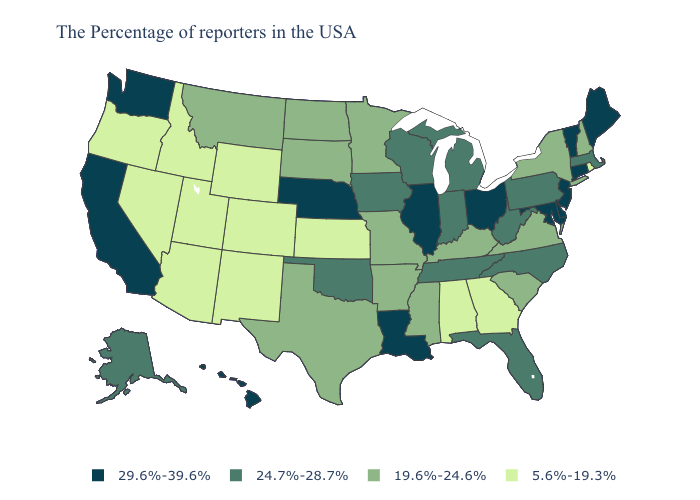Does Massachusetts have the highest value in the Northeast?
Write a very short answer. No. Name the states that have a value in the range 29.6%-39.6%?
Short answer required. Maine, Vermont, Connecticut, New Jersey, Delaware, Maryland, Ohio, Illinois, Louisiana, Nebraska, California, Washington, Hawaii. Name the states that have a value in the range 29.6%-39.6%?
Keep it brief. Maine, Vermont, Connecticut, New Jersey, Delaware, Maryland, Ohio, Illinois, Louisiana, Nebraska, California, Washington, Hawaii. Does the first symbol in the legend represent the smallest category?
Be succinct. No. Among the states that border Tennessee , which have the highest value?
Answer briefly. North Carolina. Does Montana have the lowest value in the USA?
Give a very brief answer. No. Is the legend a continuous bar?
Be succinct. No. Which states have the highest value in the USA?
Answer briefly. Maine, Vermont, Connecticut, New Jersey, Delaware, Maryland, Ohio, Illinois, Louisiana, Nebraska, California, Washington, Hawaii. Name the states that have a value in the range 5.6%-19.3%?
Quick response, please. Rhode Island, Georgia, Alabama, Kansas, Wyoming, Colorado, New Mexico, Utah, Arizona, Idaho, Nevada, Oregon. What is the value of Nebraska?
Concise answer only. 29.6%-39.6%. Does Maine have the highest value in the USA?
Keep it brief. Yes. Name the states that have a value in the range 29.6%-39.6%?
Be succinct. Maine, Vermont, Connecticut, New Jersey, Delaware, Maryland, Ohio, Illinois, Louisiana, Nebraska, California, Washington, Hawaii. Is the legend a continuous bar?
Concise answer only. No. What is the value of Wyoming?
Write a very short answer. 5.6%-19.3%. Name the states that have a value in the range 5.6%-19.3%?
Short answer required. Rhode Island, Georgia, Alabama, Kansas, Wyoming, Colorado, New Mexico, Utah, Arizona, Idaho, Nevada, Oregon. 